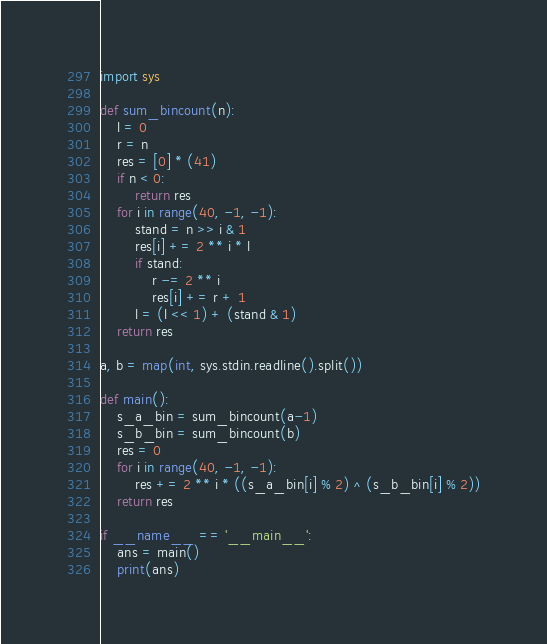<code> <loc_0><loc_0><loc_500><loc_500><_Python_>import sys

def sum_bincount(n):
    l = 0
    r = n
    res = [0] * (41)
    if n < 0:
        return res
    for i in range(40, -1, -1):
        stand = n >> i & 1
        res[i] += 2 ** i * l
        if stand:
            r -= 2 ** i
            res[i] += r + 1
        l = (l << 1) + (stand & 1)
    return res

a, b = map(int, sys.stdin.readline().split())

def main():
    s_a_bin = sum_bincount(a-1)
    s_b_bin = sum_bincount(b)
    res = 0
    for i in range(40, -1, -1):
        res += 2 ** i * ((s_a_bin[i] % 2) ^ (s_b_bin[i] % 2))
    return res

if __name__ == '__main__':
    ans = main()
    print(ans)</code> 